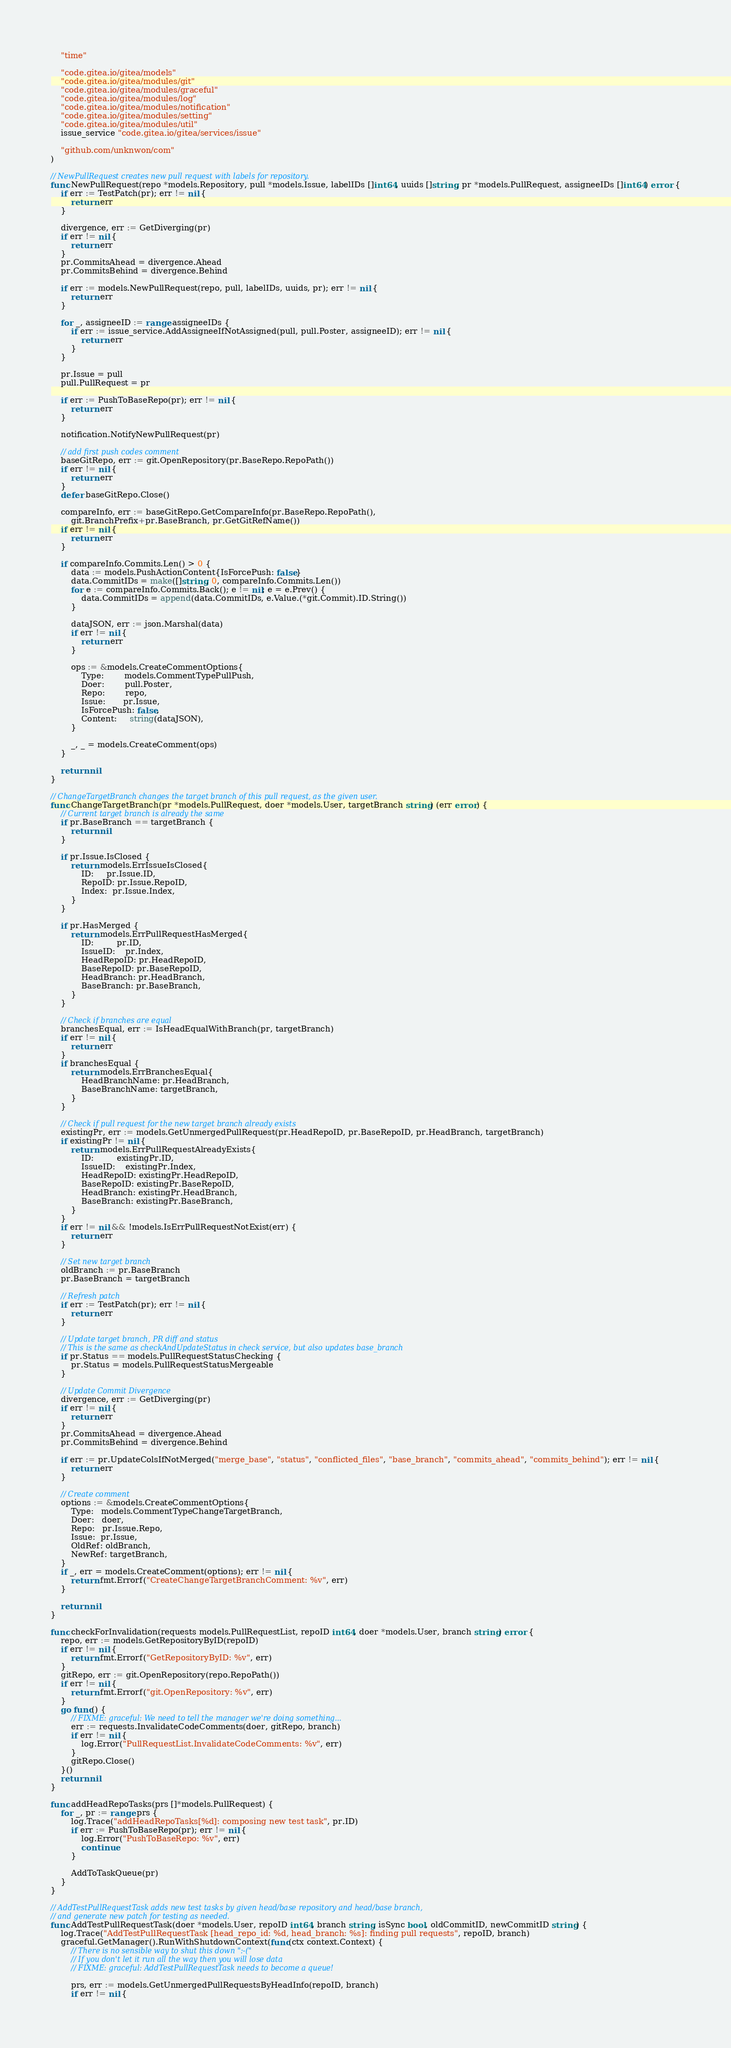Convert code to text. <code><loc_0><loc_0><loc_500><loc_500><_Go_>	"time"

	"code.gitea.io/gitea/models"
	"code.gitea.io/gitea/modules/git"
	"code.gitea.io/gitea/modules/graceful"
	"code.gitea.io/gitea/modules/log"
	"code.gitea.io/gitea/modules/notification"
	"code.gitea.io/gitea/modules/setting"
	"code.gitea.io/gitea/modules/util"
	issue_service "code.gitea.io/gitea/services/issue"

	"github.com/unknwon/com"
)

// NewPullRequest creates new pull request with labels for repository.
func NewPullRequest(repo *models.Repository, pull *models.Issue, labelIDs []int64, uuids []string, pr *models.PullRequest, assigneeIDs []int64) error {
	if err := TestPatch(pr); err != nil {
		return err
	}

	divergence, err := GetDiverging(pr)
	if err != nil {
		return err
	}
	pr.CommitsAhead = divergence.Ahead
	pr.CommitsBehind = divergence.Behind

	if err := models.NewPullRequest(repo, pull, labelIDs, uuids, pr); err != nil {
		return err
	}

	for _, assigneeID := range assigneeIDs {
		if err := issue_service.AddAssigneeIfNotAssigned(pull, pull.Poster, assigneeID); err != nil {
			return err
		}
	}

	pr.Issue = pull
	pull.PullRequest = pr

	if err := PushToBaseRepo(pr); err != nil {
		return err
	}

	notification.NotifyNewPullRequest(pr)

	// add first push codes comment
	baseGitRepo, err := git.OpenRepository(pr.BaseRepo.RepoPath())
	if err != nil {
		return err
	}
	defer baseGitRepo.Close()

	compareInfo, err := baseGitRepo.GetCompareInfo(pr.BaseRepo.RepoPath(),
		git.BranchPrefix+pr.BaseBranch, pr.GetGitRefName())
	if err != nil {
		return err
	}

	if compareInfo.Commits.Len() > 0 {
		data := models.PushActionContent{IsForcePush: false}
		data.CommitIDs = make([]string, 0, compareInfo.Commits.Len())
		for e := compareInfo.Commits.Back(); e != nil; e = e.Prev() {
			data.CommitIDs = append(data.CommitIDs, e.Value.(*git.Commit).ID.String())
		}

		dataJSON, err := json.Marshal(data)
		if err != nil {
			return err
		}

		ops := &models.CreateCommentOptions{
			Type:        models.CommentTypePullPush,
			Doer:        pull.Poster,
			Repo:        repo,
			Issue:       pr.Issue,
			IsForcePush: false,
			Content:     string(dataJSON),
		}

		_, _ = models.CreateComment(ops)
	}

	return nil
}

// ChangeTargetBranch changes the target branch of this pull request, as the given user.
func ChangeTargetBranch(pr *models.PullRequest, doer *models.User, targetBranch string) (err error) {
	// Current target branch is already the same
	if pr.BaseBranch == targetBranch {
		return nil
	}

	if pr.Issue.IsClosed {
		return models.ErrIssueIsClosed{
			ID:     pr.Issue.ID,
			RepoID: pr.Issue.RepoID,
			Index:  pr.Issue.Index,
		}
	}

	if pr.HasMerged {
		return models.ErrPullRequestHasMerged{
			ID:         pr.ID,
			IssueID:    pr.Index,
			HeadRepoID: pr.HeadRepoID,
			BaseRepoID: pr.BaseRepoID,
			HeadBranch: pr.HeadBranch,
			BaseBranch: pr.BaseBranch,
		}
	}

	// Check if branches are equal
	branchesEqual, err := IsHeadEqualWithBranch(pr, targetBranch)
	if err != nil {
		return err
	}
	if branchesEqual {
		return models.ErrBranchesEqual{
			HeadBranchName: pr.HeadBranch,
			BaseBranchName: targetBranch,
		}
	}

	// Check if pull request for the new target branch already exists
	existingPr, err := models.GetUnmergedPullRequest(pr.HeadRepoID, pr.BaseRepoID, pr.HeadBranch, targetBranch)
	if existingPr != nil {
		return models.ErrPullRequestAlreadyExists{
			ID:         existingPr.ID,
			IssueID:    existingPr.Index,
			HeadRepoID: existingPr.HeadRepoID,
			BaseRepoID: existingPr.BaseRepoID,
			HeadBranch: existingPr.HeadBranch,
			BaseBranch: existingPr.BaseBranch,
		}
	}
	if err != nil && !models.IsErrPullRequestNotExist(err) {
		return err
	}

	// Set new target branch
	oldBranch := pr.BaseBranch
	pr.BaseBranch = targetBranch

	// Refresh patch
	if err := TestPatch(pr); err != nil {
		return err
	}

	// Update target branch, PR diff and status
	// This is the same as checkAndUpdateStatus in check service, but also updates base_branch
	if pr.Status == models.PullRequestStatusChecking {
		pr.Status = models.PullRequestStatusMergeable
	}

	// Update Commit Divergence
	divergence, err := GetDiverging(pr)
	if err != nil {
		return err
	}
	pr.CommitsAhead = divergence.Ahead
	pr.CommitsBehind = divergence.Behind

	if err := pr.UpdateColsIfNotMerged("merge_base", "status", "conflicted_files", "base_branch", "commits_ahead", "commits_behind"); err != nil {
		return err
	}

	// Create comment
	options := &models.CreateCommentOptions{
		Type:   models.CommentTypeChangeTargetBranch,
		Doer:   doer,
		Repo:   pr.Issue.Repo,
		Issue:  pr.Issue,
		OldRef: oldBranch,
		NewRef: targetBranch,
	}
	if _, err = models.CreateComment(options); err != nil {
		return fmt.Errorf("CreateChangeTargetBranchComment: %v", err)
	}

	return nil
}

func checkForInvalidation(requests models.PullRequestList, repoID int64, doer *models.User, branch string) error {
	repo, err := models.GetRepositoryByID(repoID)
	if err != nil {
		return fmt.Errorf("GetRepositoryByID: %v", err)
	}
	gitRepo, err := git.OpenRepository(repo.RepoPath())
	if err != nil {
		return fmt.Errorf("git.OpenRepository: %v", err)
	}
	go func() {
		// FIXME: graceful: We need to tell the manager we're doing something...
		err := requests.InvalidateCodeComments(doer, gitRepo, branch)
		if err != nil {
			log.Error("PullRequestList.InvalidateCodeComments: %v", err)
		}
		gitRepo.Close()
	}()
	return nil
}

func addHeadRepoTasks(prs []*models.PullRequest) {
	for _, pr := range prs {
		log.Trace("addHeadRepoTasks[%d]: composing new test task", pr.ID)
		if err := PushToBaseRepo(pr); err != nil {
			log.Error("PushToBaseRepo: %v", err)
			continue
		}

		AddToTaskQueue(pr)
	}
}

// AddTestPullRequestTask adds new test tasks by given head/base repository and head/base branch,
// and generate new patch for testing as needed.
func AddTestPullRequestTask(doer *models.User, repoID int64, branch string, isSync bool, oldCommitID, newCommitID string) {
	log.Trace("AddTestPullRequestTask [head_repo_id: %d, head_branch: %s]: finding pull requests", repoID, branch)
	graceful.GetManager().RunWithShutdownContext(func(ctx context.Context) {
		// There is no sensible way to shut this down ":-("
		// If you don't let it run all the way then you will lose data
		// FIXME: graceful: AddTestPullRequestTask needs to become a queue!

		prs, err := models.GetUnmergedPullRequestsByHeadInfo(repoID, branch)
		if err != nil {</code> 